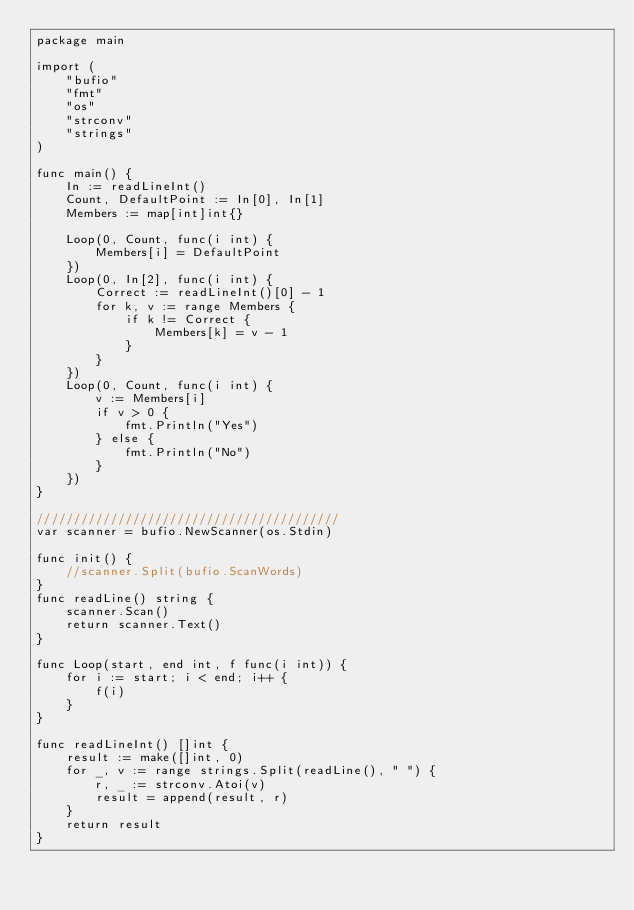Convert code to text. <code><loc_0><loc_0><loc_500><loc_500><_Go_>package main

import (
	"bufio"
	"fmt"
	"os"
	"strconv"
	"strings"
)

func main() {
	In := readLineInt()
	Count, DefaultPoint := In[0], In[1]
	Members := map[int]int{}

	Loop(0, Count, func(i int) {
		Members[i] = DefaultPoint
	})
	Loop(0, In[2], func(i int) {
		Correct := readLineInt()[0] - 1
		for k, v := range Members {
			if k != Correct {
				Members[k] = v - 1
			}
		}
	})
	Loop(0, Count, func(i int) {
		v := Members[i]
		if v > 0 {
			fmt.Println("Yes")
		} else {
			fmt.Println("No")
		}
	})
}

/////////////////////////////////////////
var scanner = bufio.NewScanner(os.Stdin)

func init() {
	//scanner.Split(bufio.ScanWords)
}
func readLine() string {
	scanner.Scan()
	return scanner.Text()
}

func Loop(start, end int, f func(i int)) {
	for i := start; i < end; i++ {
		f(i)
	}
}

func readLineInt() []int {
	result := make([]int, 0)
	for _, v := range strings.Split(readLine(), " ") {
		r, _ := strconv.Atoi(v)
		result = append(result, r)
	}
	return result
}
</code> 